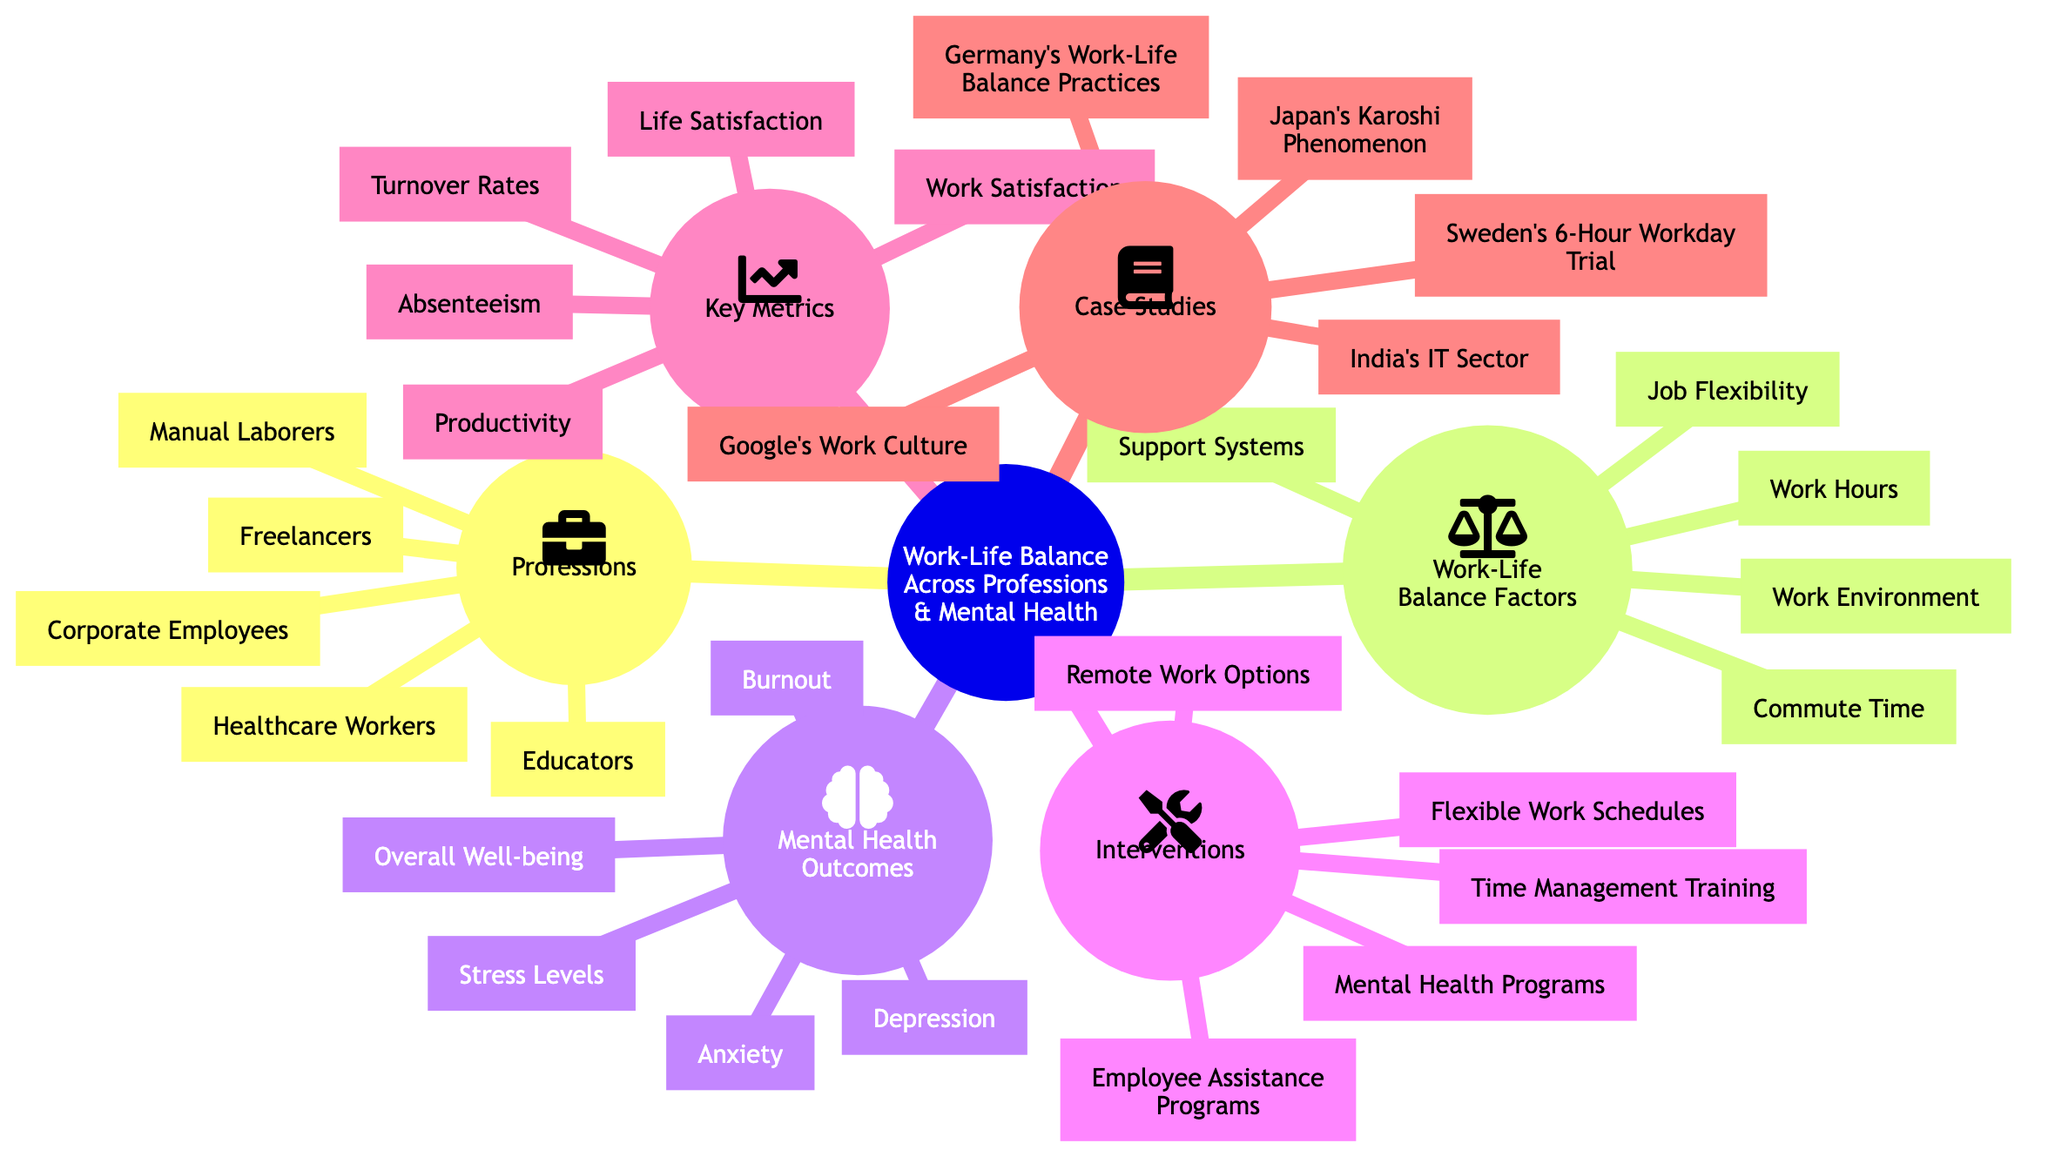What are the professions listed in the diagram? The diagram lists five professions: Healthcare Workers, Corporate Employees, Freelancers, Educators, and Manual Laborers. Each profession is a distinct element under the "Professions" subtopic.
Answer: Healthcare Workers, Corporate Employees, Freelancers, Educators, Manual Laborers How many factors of work-life balance are identified? There are five identified factors under the "Work-Life Balance Factors" subtopic: Work Hours, Job Flexibility, Commute Time, Work Environment, and Support Systems. Counting these elements gives the total number of work-life balance factors.
Answer: 5 Which mental health outcome is mentioned last? The last mental health outcome listed under the "Mental Health Outcomes" subtopic is Overall Well-being. By reviewing the order of the elements in this subtopic, this is identified as the final item.
Answer: Overall Well-being What is one intervention aimed at improving work-life balance? The diagram lists several interventions; one of them is Flexible Work Schedules. This can be found under the "Interventions" subtopic, signifying a specific measure that can be implemented.
Answer: Flexible Work Schedules Which case study addresses work culture specifically? The case study that addresses work culture specifically is Google's Work Culture. This can be derived by looking at the "Case Studies" subtopic and identifying the element that focuses on corporate work culture.
Answer: Google's Work Culture How many key metrics are listed in the diagram? There are five key metrics identified in the "Key Metrics" subtopic: Work Satisfaction, Life Satisfaction, Absenteeism, Productivity, and Turnover Rates. Counting these elements confirms the total number of metrics present.
Answer: 5 What is the relationship between Job Flexibility and Burnout? While the diagram does not explicitly show a direct relationship between Job Flexibility and Burnout, both elements are part of different subtopics that can influence each other, as interventions like Job Flexibility can potentially reduce burnout levels among workers. To answer precisely, we look at the connections among subtopics to deduce the indirect influence.
Answer: Indirect relationship Which profession is most commonly associated with high stress levels? While the diagram does not directly state which profession is most associated, it generally implies that Healthcare Workers often experience high stress levels due to the demanding nature of their job. This insight can be drawn from understanding the mental health outcomes related to different professions.
Answer: Healthcare Workers What intervention is aimed at providing mental health support? One intervention aimed at mental health support is Employee Assistance Programs. This can be identified under the "Interventions" subtopic, specifically referencing programs designed to aid employees' mental health.
Answer: Employee Assistance Programs 